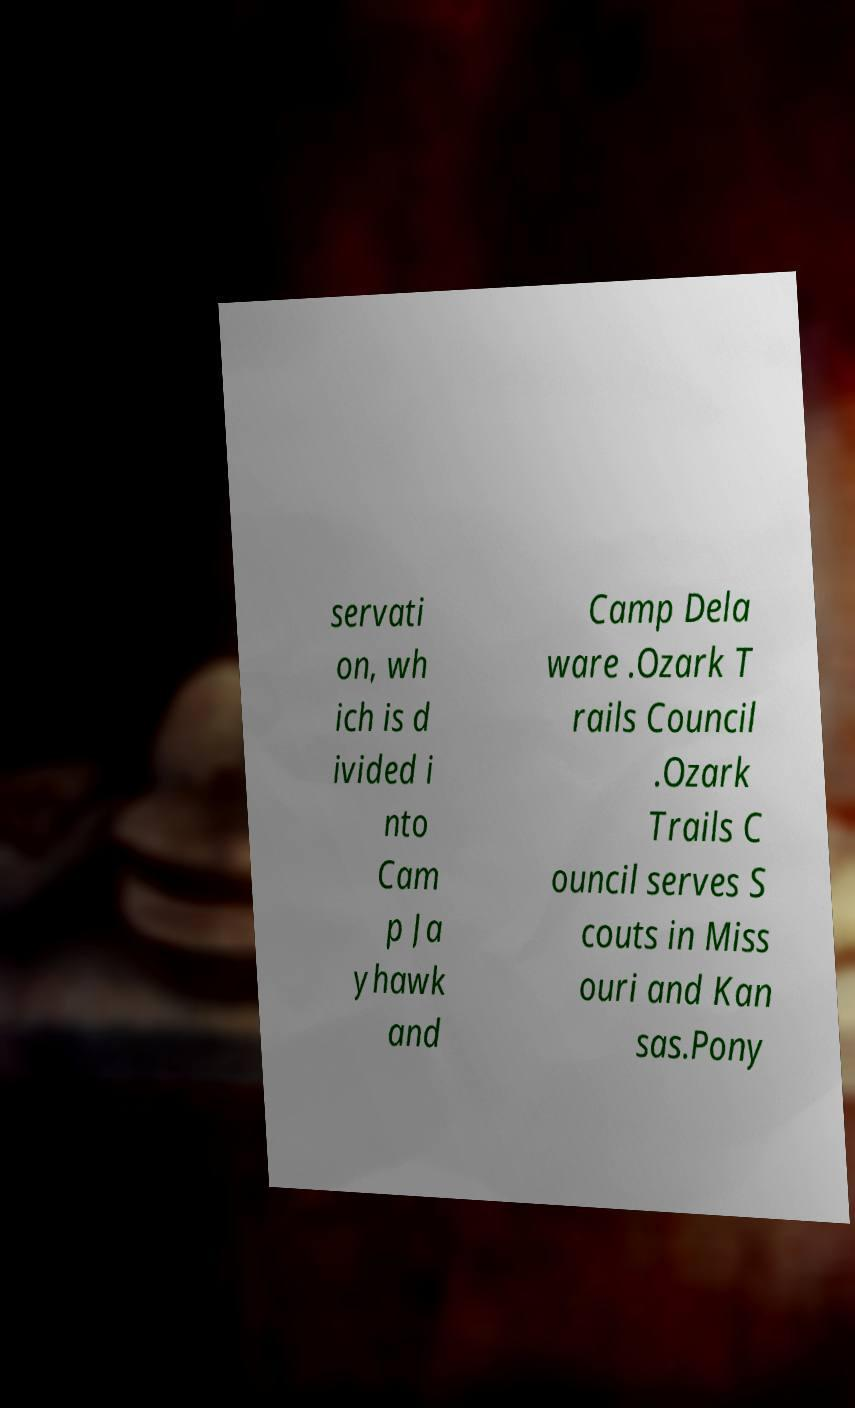I need the written content from this picture converted into text. Can you do that? servati on, wh ich is d ivided i nto Cam p Ja yhawk and Camp Dela ware .Ozark T rails Council .Ozark Trails C ouncil serves S couts in Miss ouri and Kan sas.Pony 